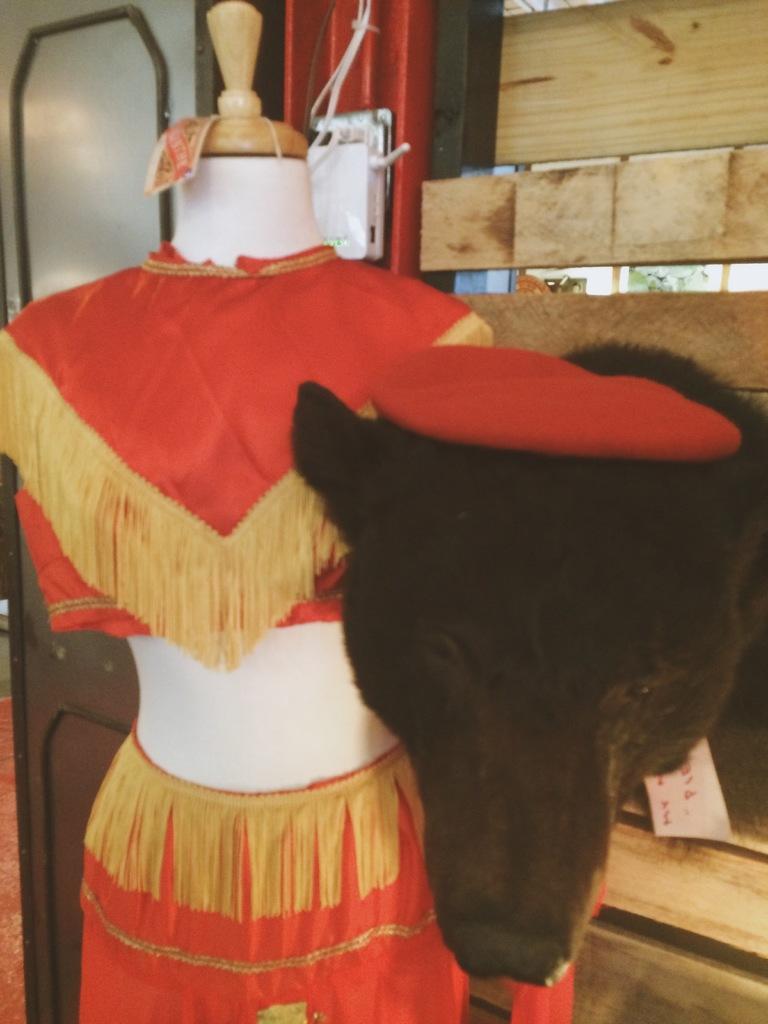In one or two sentences, can you explain what this image depicts? There is a mannequin and there is an orange dress worn by mannequin and there is an animal beside the mannequin and in the background there is a wooden wall and beside that there is a door. 